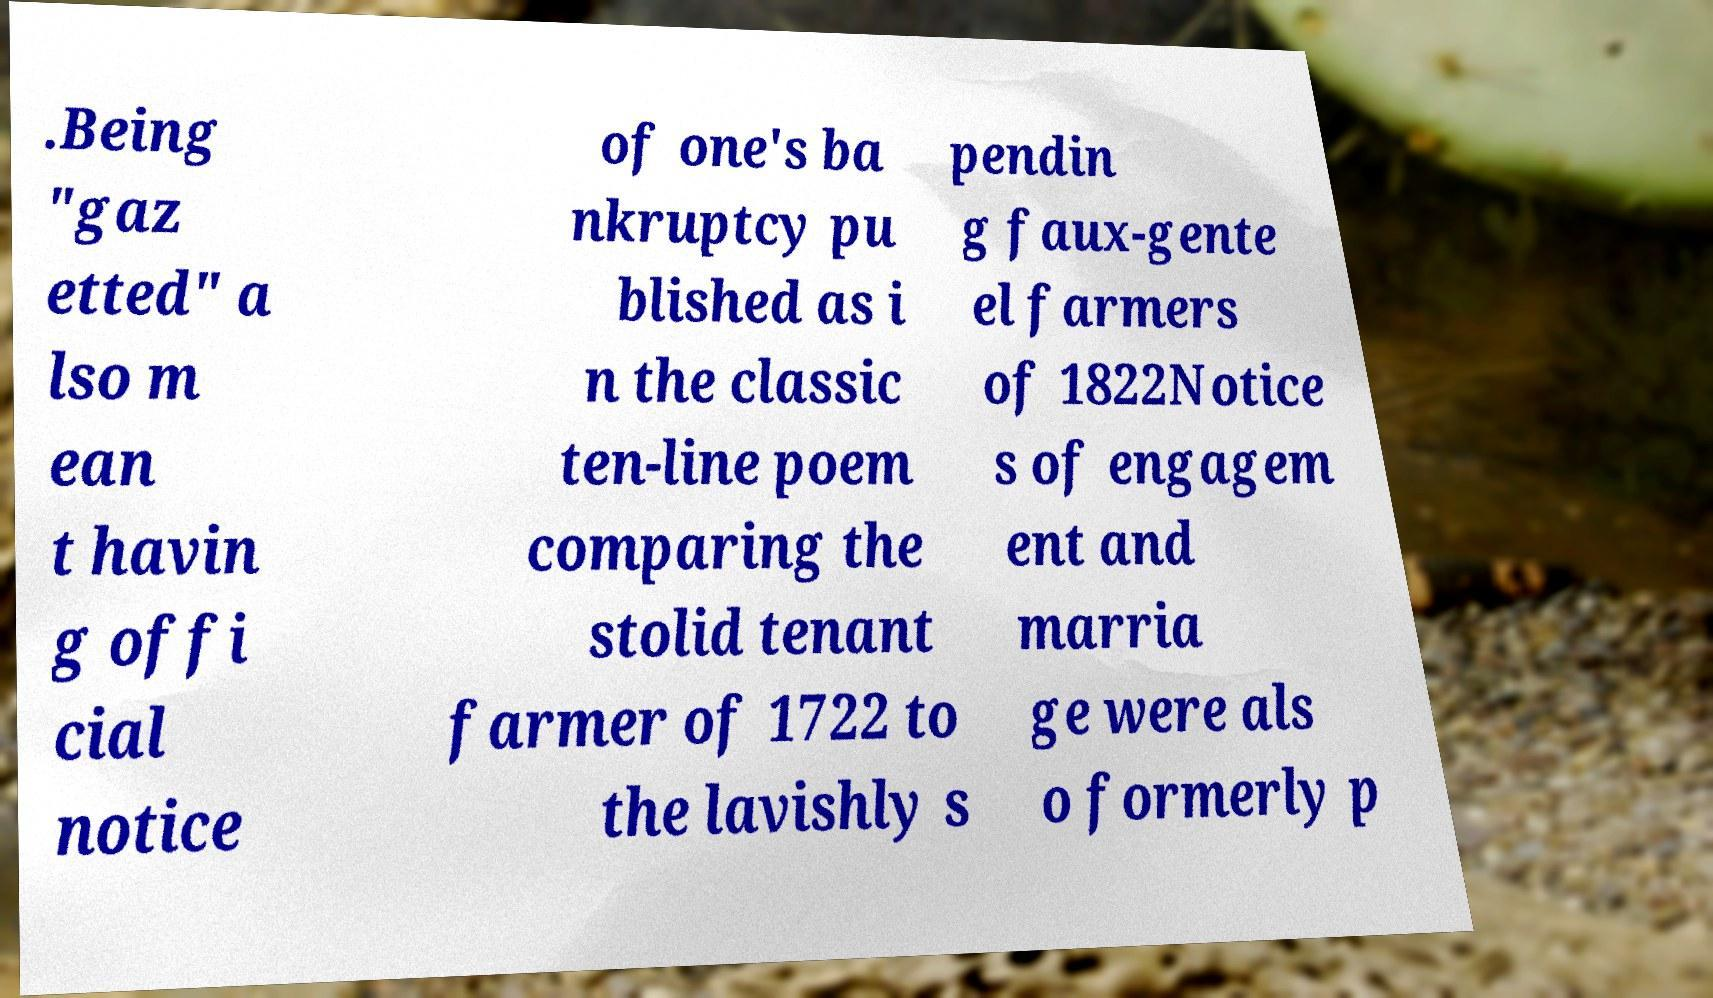For documentation purposes, I need the text within this image transcribed. Could you provide that? .Being "gaz etted" a lso m ean t havin g offi cial notice of one's ba nkruptcy pu blished as i n the classic ten-line poem comparing the stolid tenant farmer of 1722 to the lavishly s pendin g faux-gente el farmers of 1822Notice s of engagem ent and marria ge were als o formerly p 